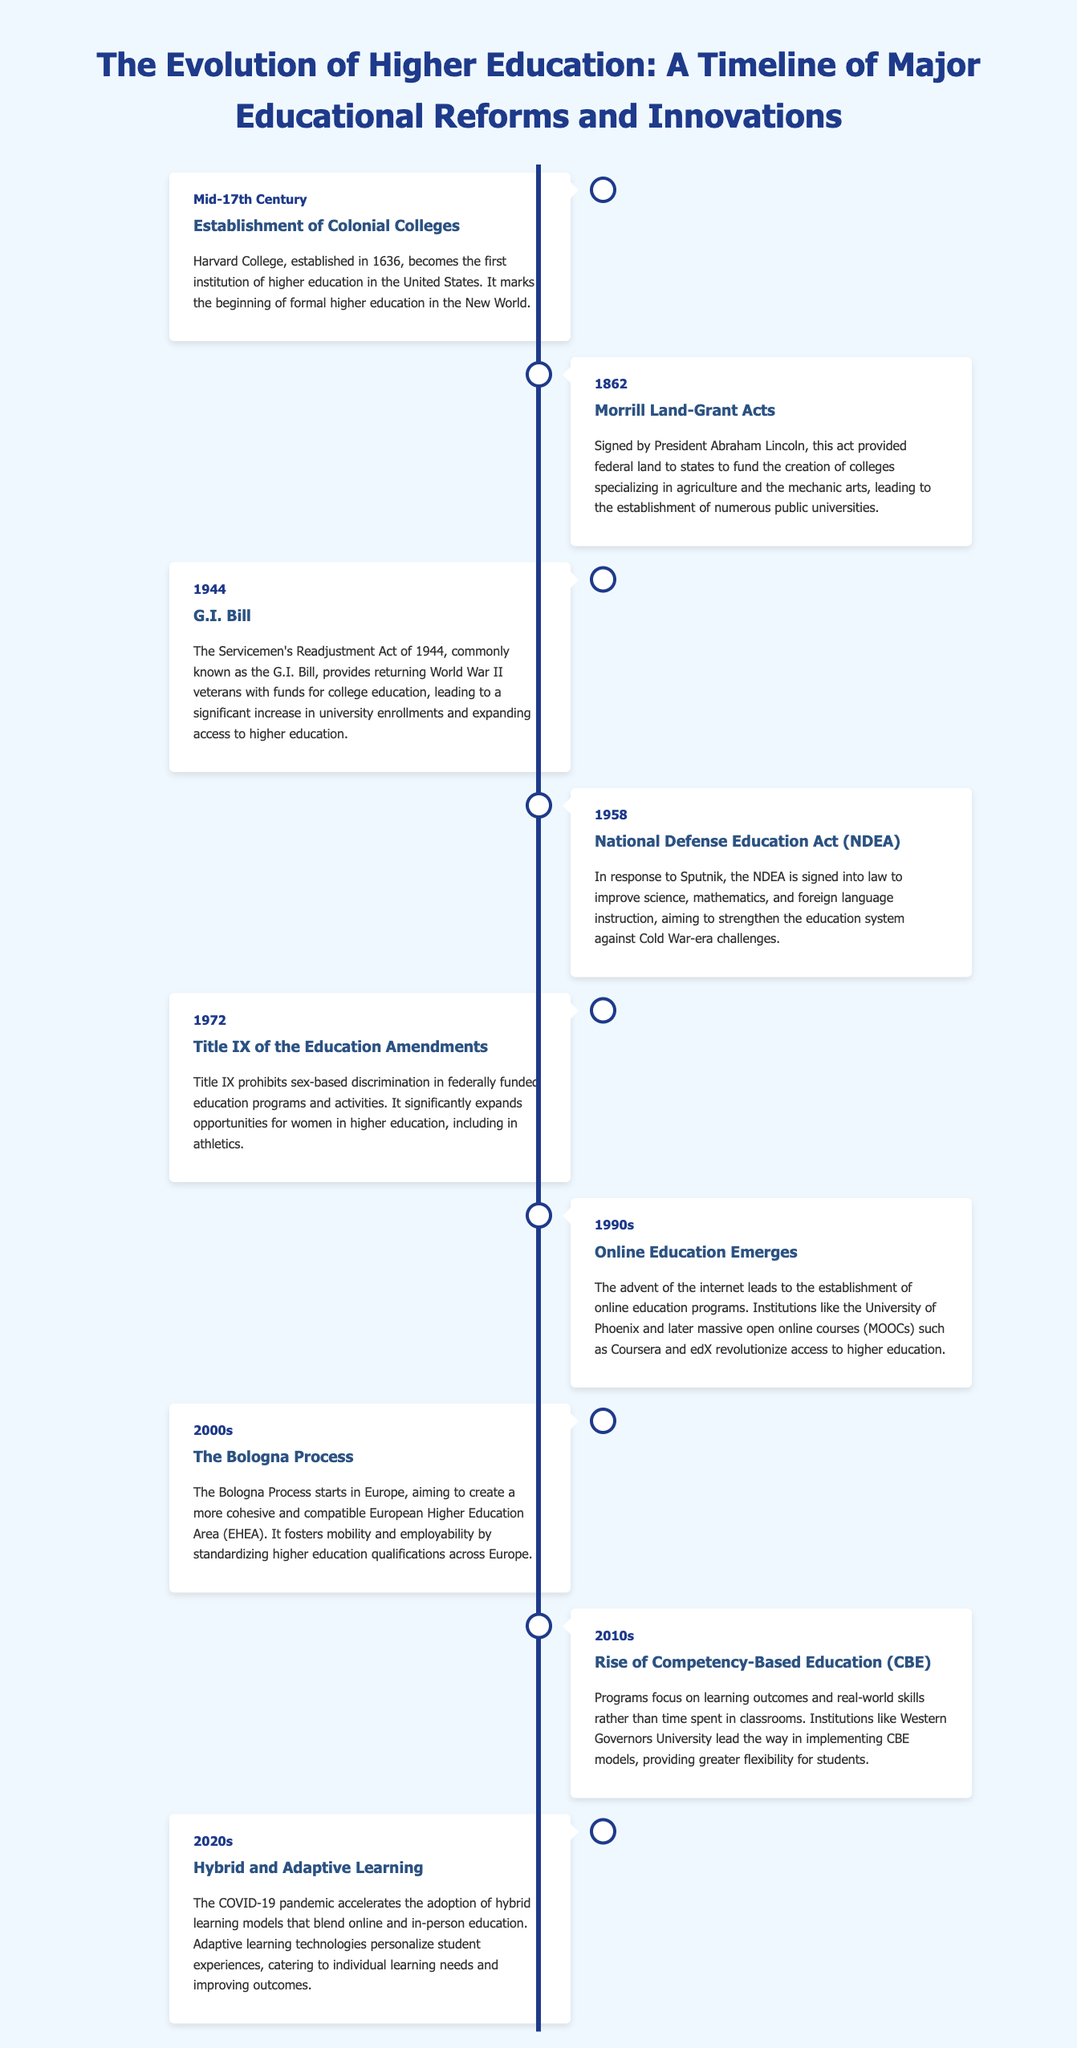What year was Harvard College established? Harvard College was established in 1636, marking the beginning of formal higher education in the New World.
Answer: 1636 What act did Abraham Lincoln sign in 1862? The Morrill Land-Grant Acts were signed by President Abraham Lincoln in 1862 to provide federal land for creating colleges.
Answer: Morrill Land-Grant Acts What major education program was initiated in 1944? The G.I. Bill, or Servicemen's Readjustment Act, was enacted to support returning World War II veterans with college funds.
Answer: G.I. Bill What did the National Defense Education Act aim to improve? The NDEA aimed to improve science, mathematics, and foreign language instruction in response to the Cold War.
Answer: Science, mathematics, and foreign language instruction What significant legislation was passed in 1972? Title IX of the Education Amendments was passed, prohibiting sex-based discrimination in federally funded education programs.
Answer: Title IX What online education trend emerged in the 1990s? Online education programs began to emerge, including institutions like the University of Phoenix and later MOOCs.
Answer: Online education What educational initiative started in the 2000s in Europe? The Bologna Process was initiated in Europe to create a cohesive European Higher Education Area.
Answer: Bologna Process What type of education grew in the 2010s? Competency-Based Education (CBE) focused on learning outcomes rather than time spent in classrooms.
Answer: Competency-Based Education What learning model became prominent in the 2020s? Hybrid and adaptive learning models became prominent during the COVID-19 pandemic.
Answer: Hybrid and adaptive learning 